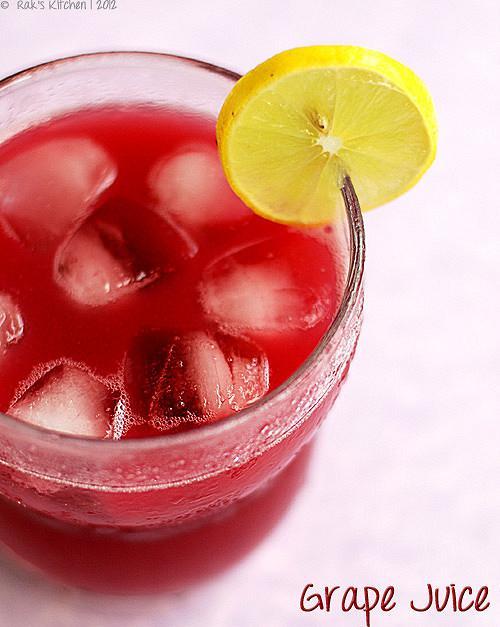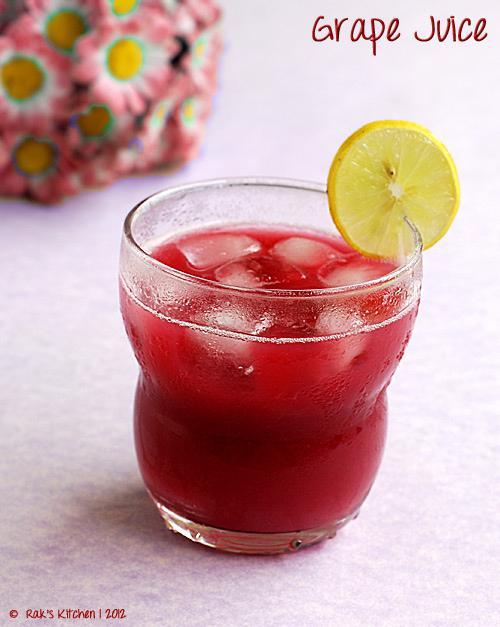The first image is the image on the left, the second image is the image on the right. For the images shown, is this caption "All of the images contain only one glass that is filled with a beverage." true? Answer yes or no. Yes. 